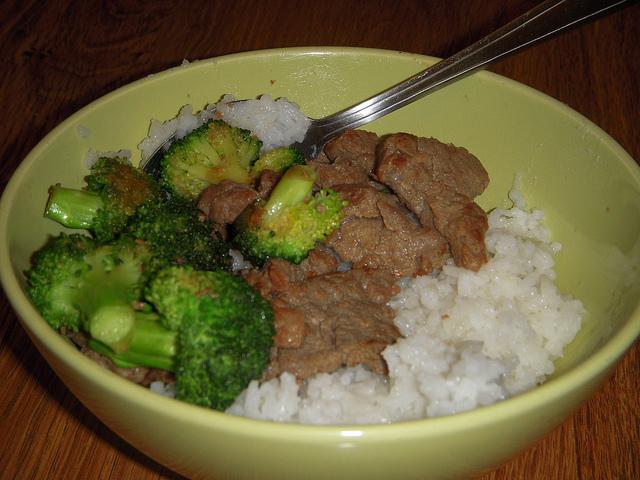What type of vegetable is in the bowl?
Answer briefly. Broccoli. What kind of meat is in this dish?
Write a very short answer. Beef. Is this food enough for two people?
Answer briefly. No. How many pieces of broccoli are in the dish?
Short answer required. 6. What is the metal object on the white dish?
Give a very brief answer. Fork. Is anyone holding this bowl?
Short answer required. No. How many servings of carbohydrates are shown?
Short answer required. 1. What color is the dish?
Keep it brief. Green. 